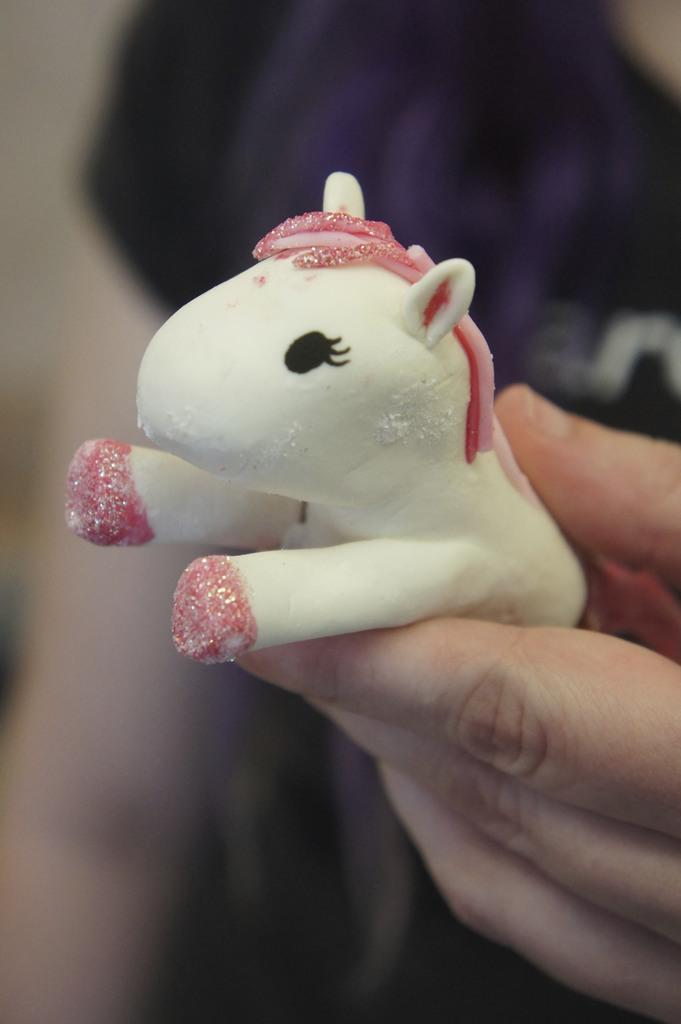What is the person's hand holding in the image? There is a person's hand holding a toy in the image. Can you describe the background of the image? The background of the image is blurry. How many sisters are present in the image? There is no mention of sisters in the image, so we cannot determine their presence. What type of care is being provided in the image? There is no indication of care being provided in the image. Are there any fairies visible in the image? There is no mention of fairies in the image, so we cannot determine their presence. 